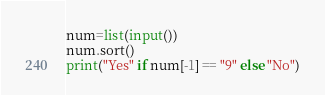Convert code to text. <code><loc_0><loc_0><loc_500><loc_500><_Python_>num=list(input())
num.sort()
print("Yes" if num[-1] == "9" else "No")</code> 